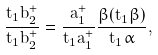<formula> <loc_0><loc_0><loc_500><loc_500>\frac { t _ { 1 } \dot { b } _ { 2 } ^ { + } } { t _ { 1 } b _ { 2 } ^ { + } } = \frac { a _ { 1 } ^ { + } } { t _ { 1 } a _ { 1 } ^ { + } } \frac { \beta ( t _ { 1 } \beta ) } { t _ { 1 } \alpha } ,</formula> 